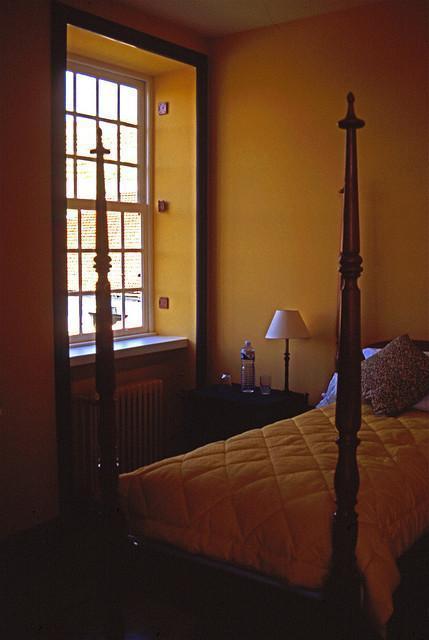How many people are meant to sleep here?
Give a very brief answer. 0. 